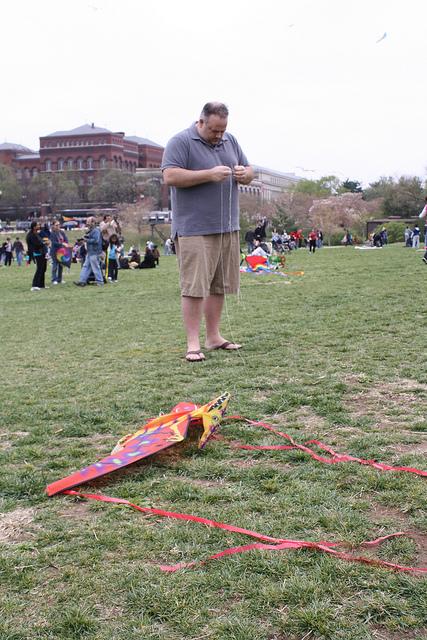Does the kite have a tail?
Answer briefly. Yes. Is this good kite flying weather?
Quick response, please. Yes. How many men are wearing shorts?
Give a very brief answer. 1. Is the kite in the air?
Keep it brief. No. 